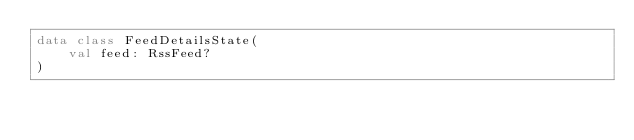Convert code to text. <code><loc_0><loc_0><loc_500><loc_500><_Kotlin_>data class FeedDetailsState(
    val feed: RssFeed?
)</code> 